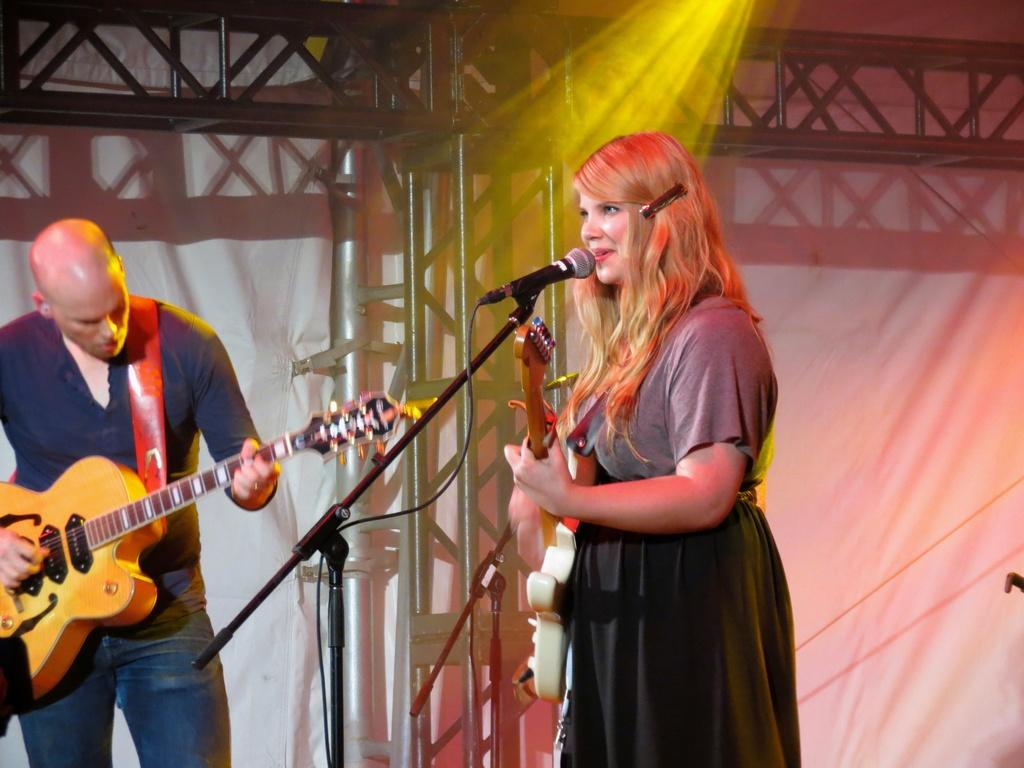What is the woman in the image doing? The woman is singing on a microphone and holding a guitar. What is the man in the image doing? The man is playing a guitar. What can be seen in the background of the image? There is a pillar, a light, and a wall in the background of the image. What type of loaf is the woman using to sing on the microphone? There is no loaf present in the image; the woman is using a microphone to sing. Can you see any writing on the wall in the background? There is no writing visible on the wall in the background of the image. 